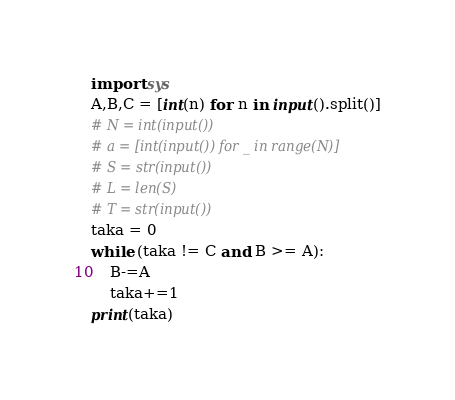Convert code to text. <code><loc_0><loc_0><loc_500><loc_500><_Python_>import sys
A,B,C = [int(n) for n in input().split()]
# N = int(input())
# a = [int(input()) for _ in range(N)]
# S = str(input())
# L = len(S)
# T = str(input())
taka = 0
while (taka != C and B >= A):
    B-=A
    taka+=1
print(taka)
</code> 